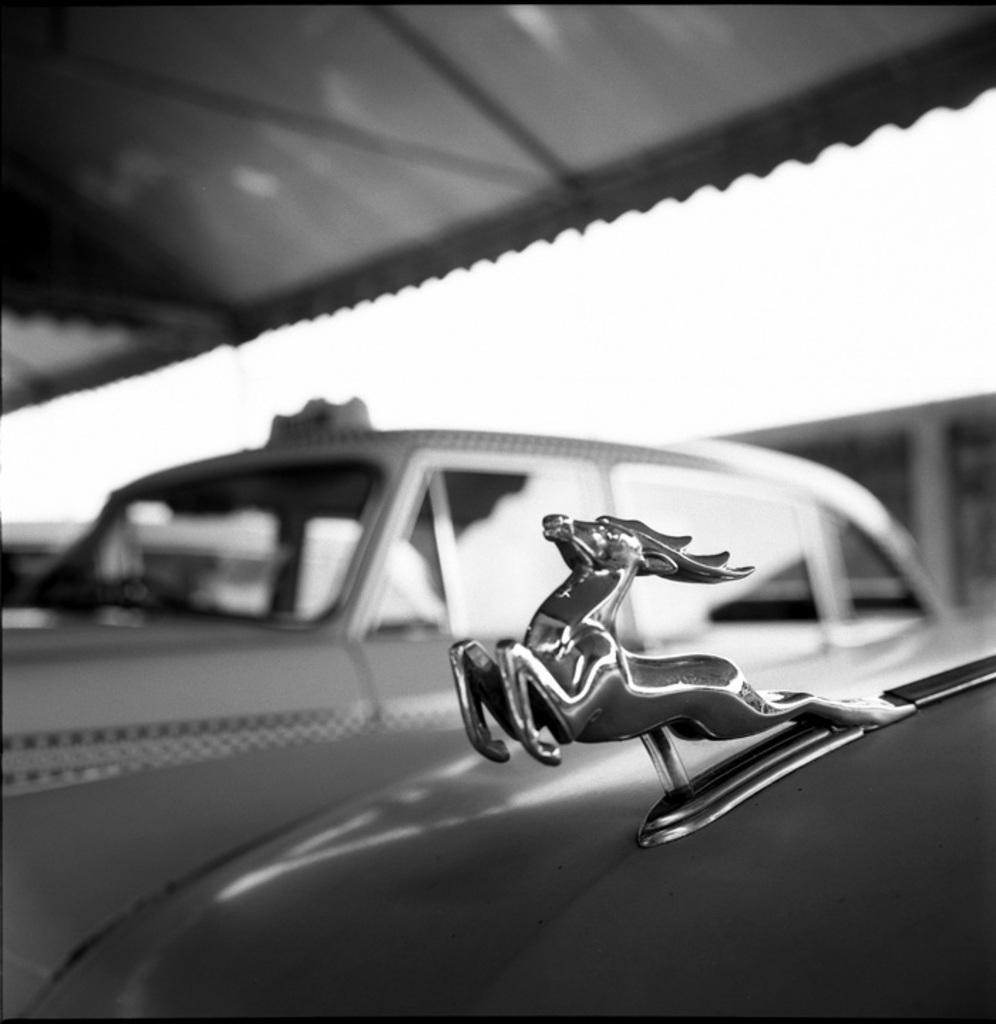What type of vehicles can be seen in the image? There are cars in the image. Are there any distinguishing features on the cars? Yes, there is a logo on one of the cars. How would you describe the quality of the image? The image is a little bit blurry. What color scheme is used in the image? The image is black and white in color. Can you see a wrench being used on the car in the image? There is no wrench visible in the image, and no indication of any maintenance or repair work being done on the cars. 